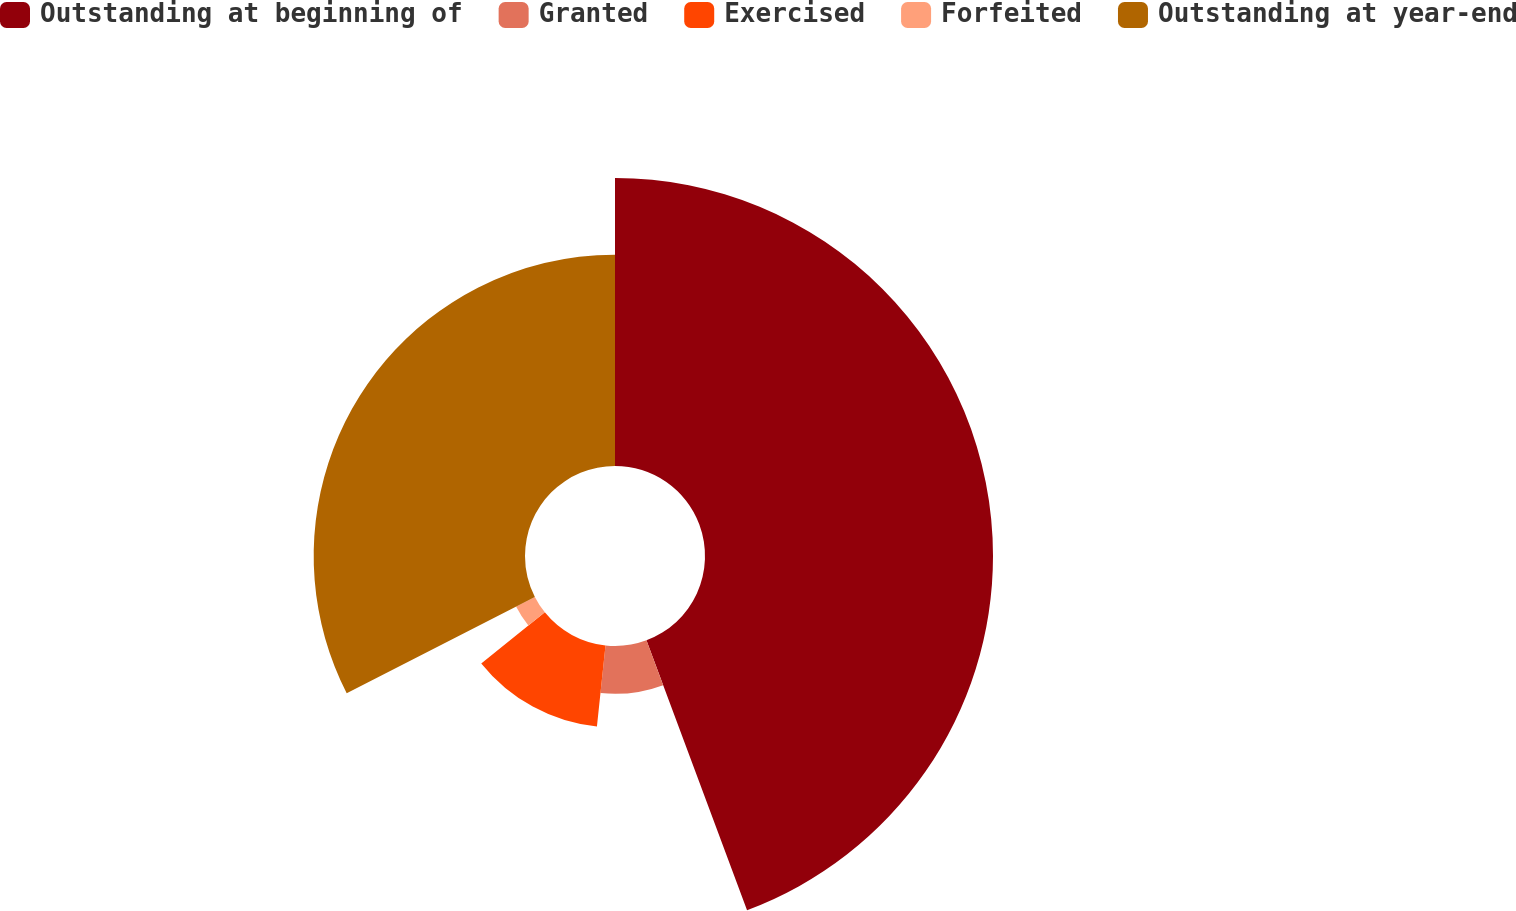Convert chart. <chart><loc_0><loc_0><loc_500><loc_500><pie_chart><fcel>Outstanding at beginning of<fcel>Granted<fcel>Exercised<fcel>Forfeited<fcel>Outstanding at year-end<nl><fcel>44.32%<fcel>7.36%<fcel>12.55%<fcel>3.25%<fcel>32.52%<nl></chart> 